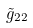Convert formula to latex. <formula><loc_0><loc_0><loc_500><loc_500>\tilde { g } _ { 2 2 }</formula> 